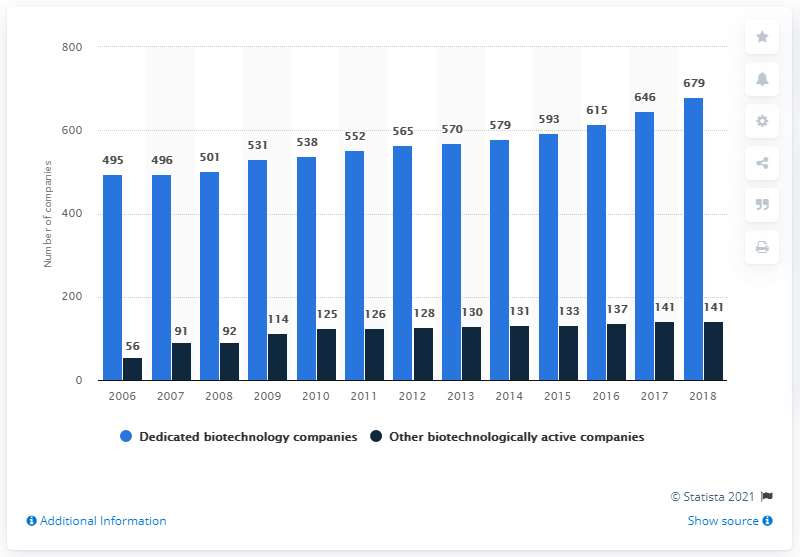How has the number of dedicated biotechnology companies changed over the years from 2006 to 2018? From 2006 to 2018, the number of dedicated biotechnology companies in Germany has experienced substantial growth, rising from 495 companies to 679. 